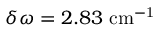Convert formula to latex. <formula><loc_0><loc_0><loc_500><loc_500>\delta \omega = 2 . 8 3 { c m ^ { - 1 } }</formula> 